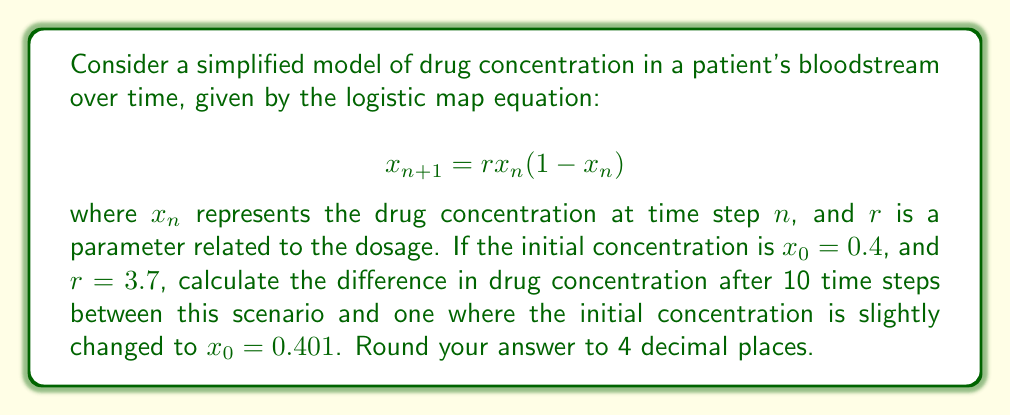What is the answer to this math problem? To solve this problem, we need to iterate the logistic map equation for both initial conditions and compare the results after 10 steps. Let's break it down:

1) For $x_0 = 0.4$ and $r = 3.7$:

   $x_1 = 3.7 * 0.4 * (1 - 0.4) = 0.888$
   $x_2 = 3.7 * 0.888 * (1 - 0.888) = 0.3678$
   $x_3 = 3.7 * 0.3678 * (1 - 0.3678) = 0.8614$
   ...
   $x_{10} = 0.3647$

2) For $x_0 = 0.401$ and $r = 3.7$:

   $x_1 = 3.7 * 0.401 * (1 - 0.401) = 0.8899$
   $x_2 = 3.7 * 0.8899 * (1 - 0.8899) = 0.3634$
   $x_3 = 3.7 * 0.3634 * (1 - 0.3634) = 0.8577$
   ...
   $x_{10} = 0.8234$

3) Calculate the difference:

   $|0.3647 - 0.8234| = 0.4587$

4) Rounding to 4 decimal places: 0.4587

This demonstrates the butterfly effect in pharmacology, where a small change in initial concentration (0.001) leads to a significant difference in drug concentration after just 10 time steps.
Answer: 0.4587 